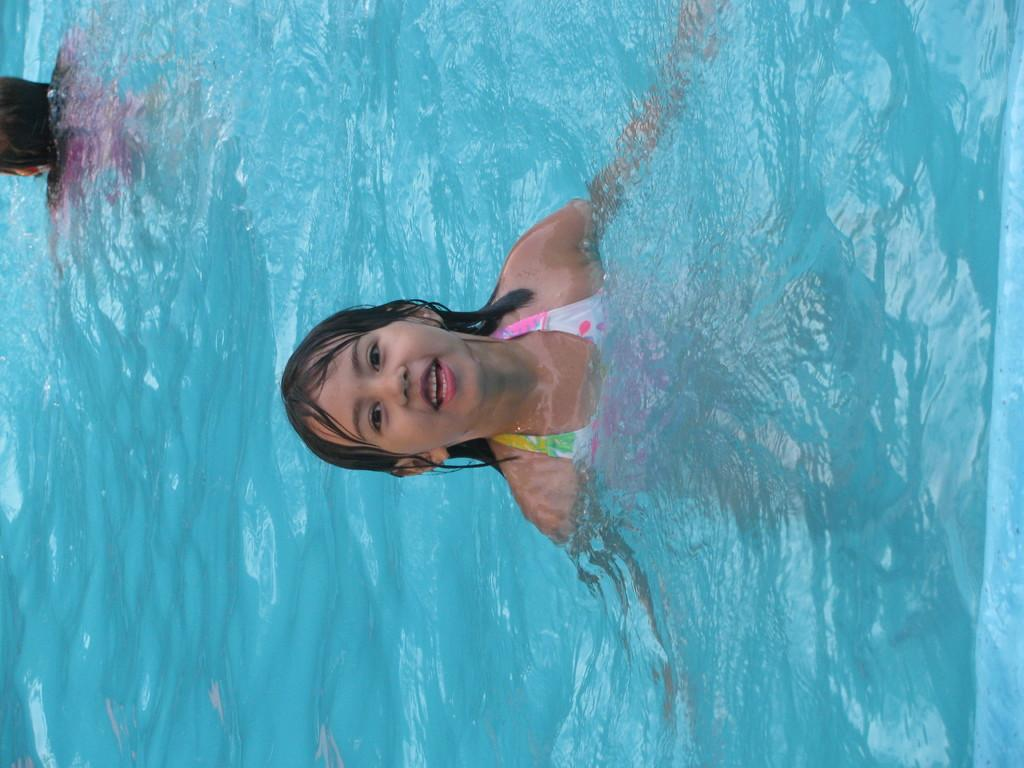What is the main subject of the image? The main subject of the image is a person in the water. Are there any other people in the image? Yes, there is another person in the water on the left side of the image. What type of pen can be seen floating in the water in the image? There is no pen present in the image; it only features two people in the water. 